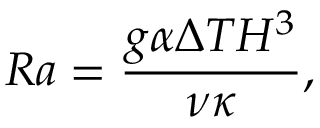<formula> <loc_0><loc_0><loc_500><loc_500>R a = \frac { g \alpha \Delta T H ^ { 3 } } { \nu \kappa } ,</formula> 